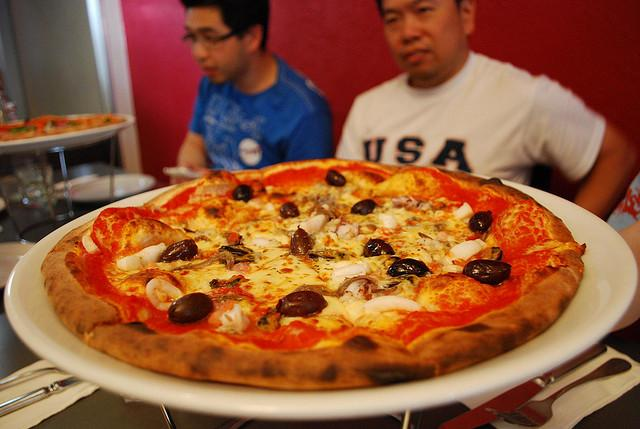What country does the shirt on the right mention?

Choices:
A) china
B) usa
C) japan
D) germany usa 